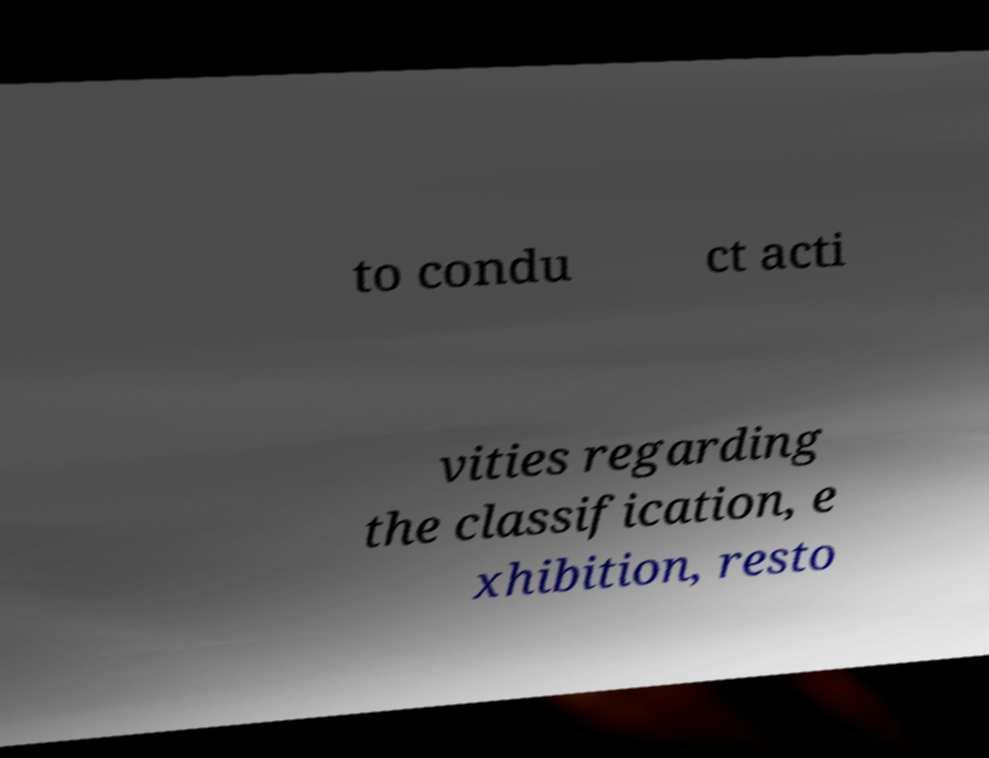What messages or text are displayed in this image? I need them in a readable, typed format. to condu ct acti vities regarding the classification, e xhibition, resto 